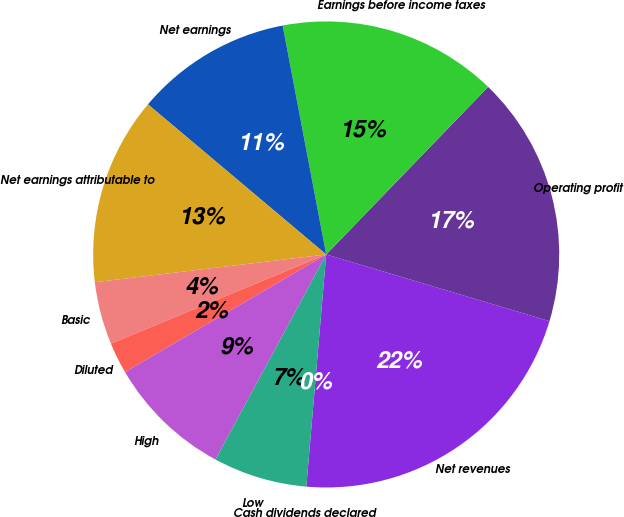<chart> <loc_0><loc_0><loc_500><loc_500><pie_chart><fcel>Net revenues<fcel>Operating profit<fcel>Earnings before income taxes<fcel>Net earnings<fcel>Net earnings attributable to<fcel>Basic<fcel>Diluted<fcel>High<fcel>Low<fcel>Cash dividends declared<nl><fcel>21.74%<fcel>17.39%<fcel>15.22%<fcel>10.87%<fcel>13.04%<fcel>4.35%<fcel>2.17%<fcel>8.7%<fcel>6.52%<fcel>0.0%<nl></chart> 